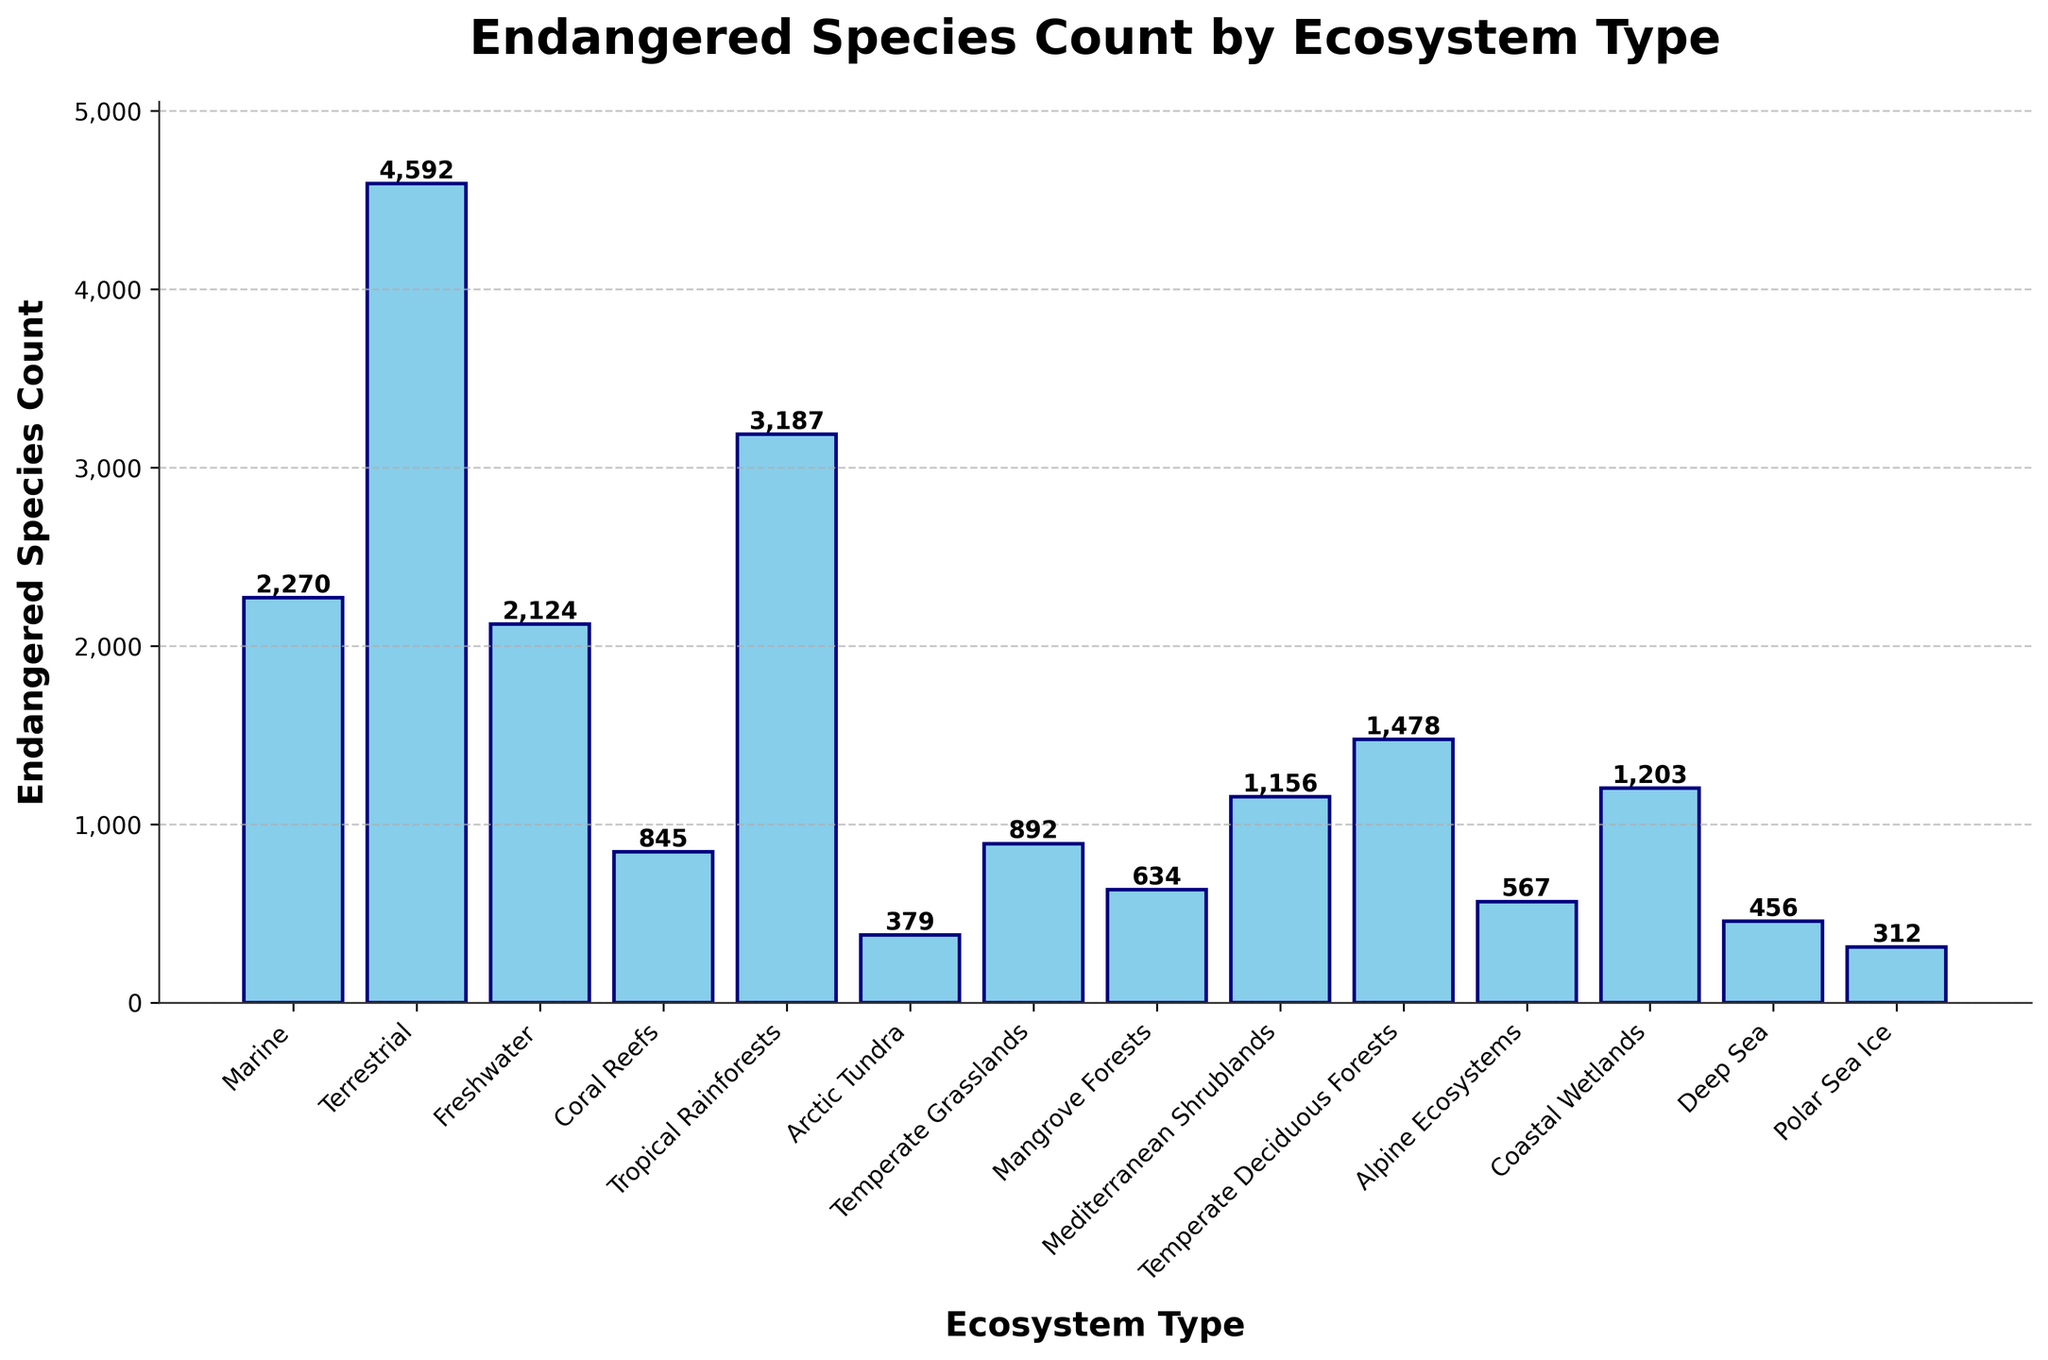Which ecosystem type has the highest number of endangered species? The bar representing Terrestrial ecosystems is the tallest, indicating the highest count of endangered species.
Answer: Terrestrial How many more endangered species are in Terrestrial ecosystems compared to Marine ecosystems? The Terrestrial ecosystem has 4592 endangered species, while the Marine ecosystem has 2270. The difference is 4592 - 2270 = 2322.
Answer: 2322 What is the total number of endangered species in the Tropical Rainforests and Coastal Wetlands ecosystems combined? Tropical Rainforests have 3187 endangered species and Coastal Wetlands have 1203. The total is 3187 + 1203 = 4390.
Answer: 4390 Which ecosystem type has fewer endangered species: Coral Reefs or Mangrove Forests? The bar for Coral Reefs represents 845 endangered species, and the bar for Mangrove Forests represents 634. Mangrove Forests have fewer endangered species.
Answer: Mangrove Forests What is the average number of endangered species across all the ecosystem types? Sum of all endangered species counts (2270 + 4592 + 2124 + 845 + 3187 + 379 + 892 + 634 + 1156 + 1478 + 567 + 1203 + 456 + 312) is 20,095. There are 14 ecosystem types. The average is 20,095 / 14 = 1435.36.
Answer: 1435.36 What is the proportion of endangered species in the Alpine Ecosystems compared to the total for all ecosystems? Alpine Ecosystems have 567 endangered species. Total endangered species count is 20,095. The proportion is 567 / 20,095 = 0.0282 or 2.82%.
Answer: 2.82% Which two ecosystem types combined have a total endangered species count closest to that of the Terrestrial ecosystems alone? Tropical Rainforests (3187) and Mediterranean Shrublands (1156) combined have 3187 + 1156 = 4343. This is closest to the Terrestrial count of 4592.
Answer: Tropical Rainforests and Mediterranean Shrublands If Marine and Freshwater ecosystems were merged into one category, how many endangered species would this new category have? Marine has 2270 endangered species and Freshwater has 2124. Combining them, the new category would have 2270 + 2124 = 4394.
Answer: 4394 